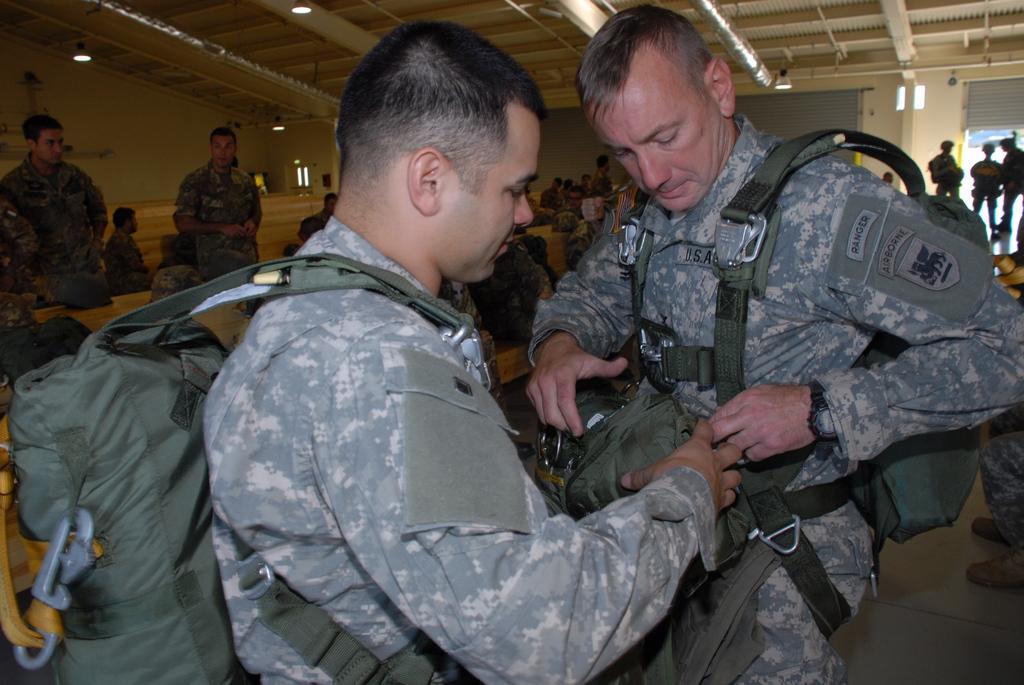In one or two sentences, can you explain what this image depicts? In the image there are two army officers and the first person is helping the other person and behind them there are many other army soldiers, in the background there is a wall and beside that there are two shutters. 